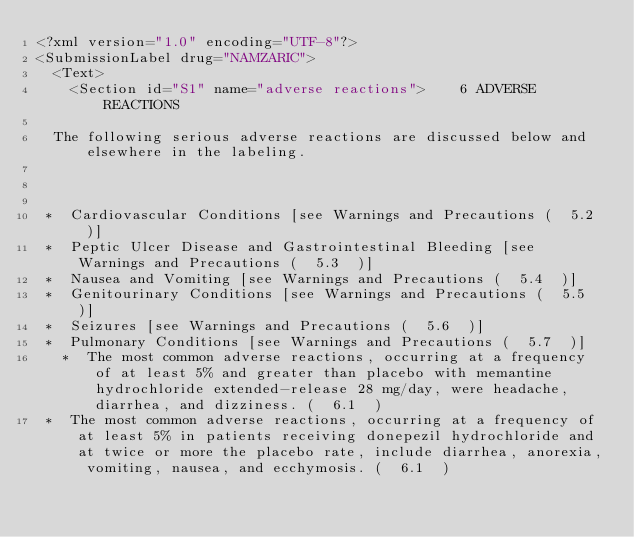Convert code to text. <code><loc_0><loc_0><loc_500><loc_500><_XML_><?xml version="1.0" encoding="UTF-8"?>
<SubmissionLabel drug="NAMZARIC">
  <Text>
    <Section id="S1" name="adverse reactions">    6 ADVERSE REACTIONS

  The following serious adverse reactions are discussed below and elsewhere in the labeling.



 *  Cardiovascular Conditions [see Warnings and Precautions (  5.2  )]  
 *  Peptic Ulcer Disease and Gastrointestinal Bleeding [see Warnings and Precautions (  5.3  )]  
 *  Nausea and Vomiting [see Warnings and Precautions (  5.4  )]  
 *  Genitourinary Conditions [see Warnings and Precautions (  5.5  )]  
 *  Seizures [see Warnings and Precautions (  5.6  )]  
 *  Pulmonary Conditions [see Warnings and Precautions (  5.7  )]  
   *  The most common adverse reactions, occurring at a frequency of at least 5% and greater than placebo with memantine hydrochloride extended-release 28 mg/day, were headache, diarrhea, and dizziness. (  6.1  ) 
 *  The most common adverse reactions, occurring at a frequency of at least 5% in patients receiving donepezil hydrochloride and at twice or more the placebo rate, include diarrhea, anorexia, vomiting, nausea, and ecchymosis. (  6.1  ) </code> 